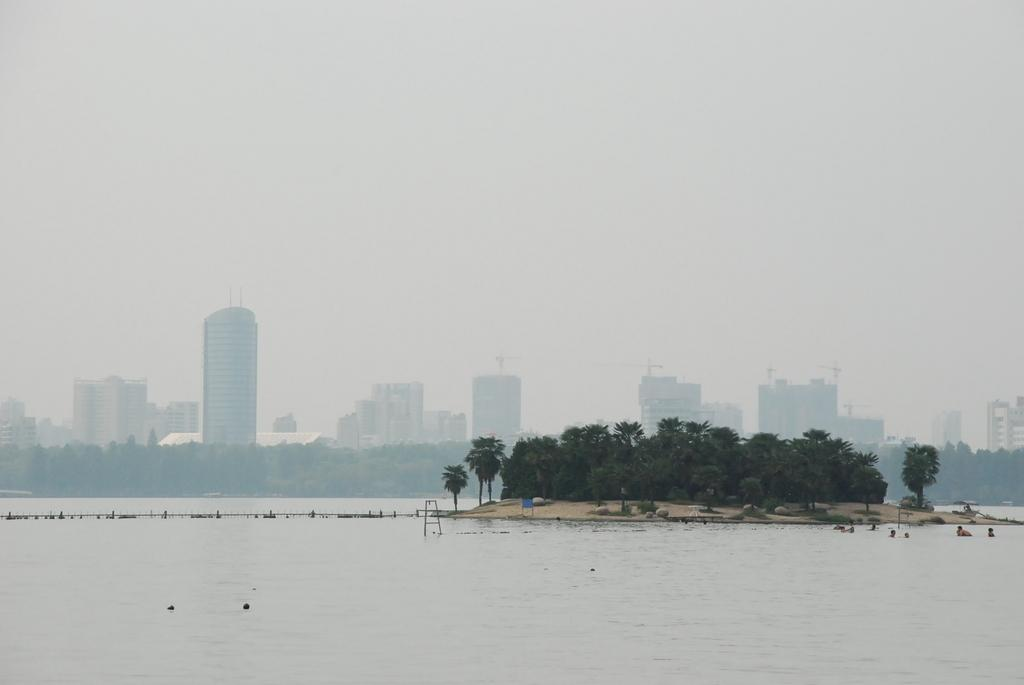What type of structures can be seen in the image? There are buildings in the image. What other natural elements are present in the image? There are trees in the image. Are there any man-made objects besides buildings? Yes, there are poles in the image. What is visible at the top of the image? The sky is visible at the top of the image. What is visible at the bottom of the image? Water is visible at the bottom of the image. What type of neck accessory is visible on the trees in the image? There are no neck accessories present on the trees in the image. Is there any indication of a holiday celebration in the image? There is no indication of a holiday celebration in the image. 